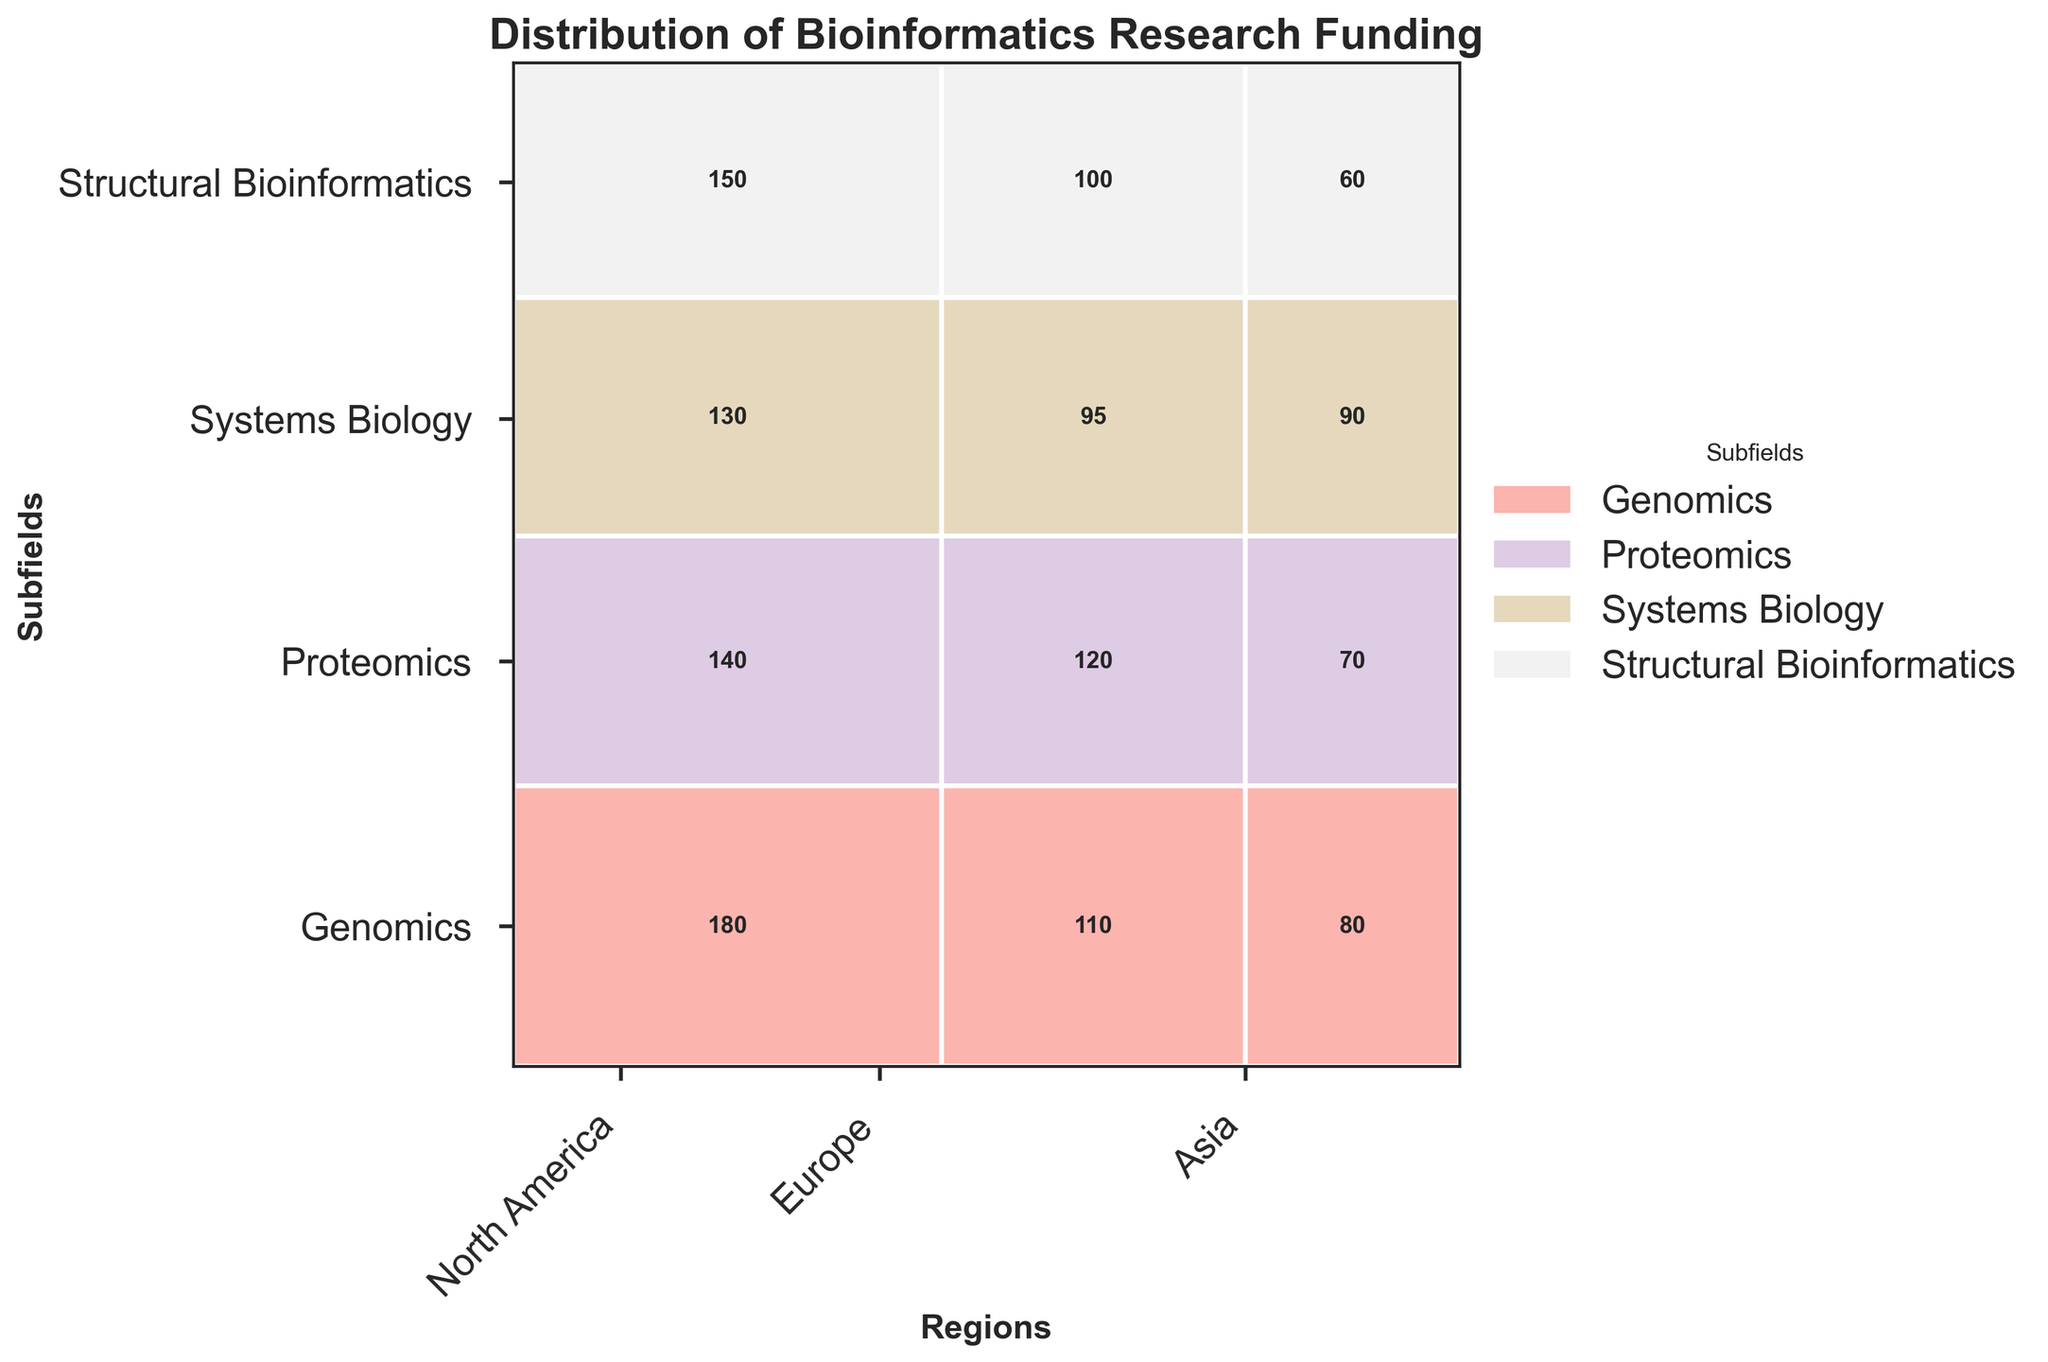What is the title of the figure? The title of the figure is located at the top and typically gives an overall summary of what the plot is about. By looking at the top of the figure, we can see the title "Distribution of Bioinformatics Research Funding".
Answer: Distribution of Bioinformatics Research Funding How many regions are represented in the figure? One can determine the number of regions by looking at the x-axis, which labels the different regions. There are three region labels present: North America, Europe, and Asia.
Answer: 3 Which subfield has the highest funding in North America? To find the subfield with the highest funding, locate the North America section on the x-axis and then identify the subfield with the largest rectangle in this section. Genomics has the largest rectangle in North America.
Answer: Genomics What is the total funding amount for Proteomics across all regions? To find the total amount, sum the funding values across all regions for Proteomics. These values are: 120 (Europe) + 70 (Asia) + 140 (North America). The total is 330.
Answer: 330 Which region has the least funding in Structural Bioinformatics? Identify the region by finding the smallest rectangle in the Structural Bioinformatics row. The smallest rectangle is in the Asia section with a funding amount of 60.
Answer: Asia What is the proportion of funding for Systems Biology in Europe compared to the total funding for Systems Biology? First, sum the funding for Systems Biology across all regions: 90 (Asia) + 130 (North America) + 95 (Europe) = 315. The Europe funding proportion is 95 out of 315. To find the proportion: 95 / 315 ≈ 0.3, or 30%.
Answer: 30% Which subfield has the smallest total funding? Sum up the funding amounts for each subfield across all regions, then identify which total is the smallest. Structural Bioinformatics has the funding amounts 150 (North America) + 100 (Europe) + 60 (Asia) = 310, which is less than the totals for the other subfields.
Answer: Structural Bioinformatics In which region does Genomics receive the least funding? Locate the rectangles corresponding to Genomics in each region. The smallest rectangle is in the Asia section with a funding amount of 80.
Answer: Asia How does the amount of funding for Systems Biology in Asia compare to that in North America? Compare the sizes of the rectangles for Systems Biology in Asia and North America. Asia has 90, while North America has 130. 130 is greater than 90.
Answer: North America has more What is the average funding across all subfields for Europe? Sum the funding for all subfields in Europe and then divide by the number of subfields. Europe has 120 (Proteomics) + 110 (Genomics) + 100 (Structural Bioinformatics) + 95 (Systems Biology) = 425. There are 4 subfields, so 425 / 4 = 106.25.
Answer: 106.25 